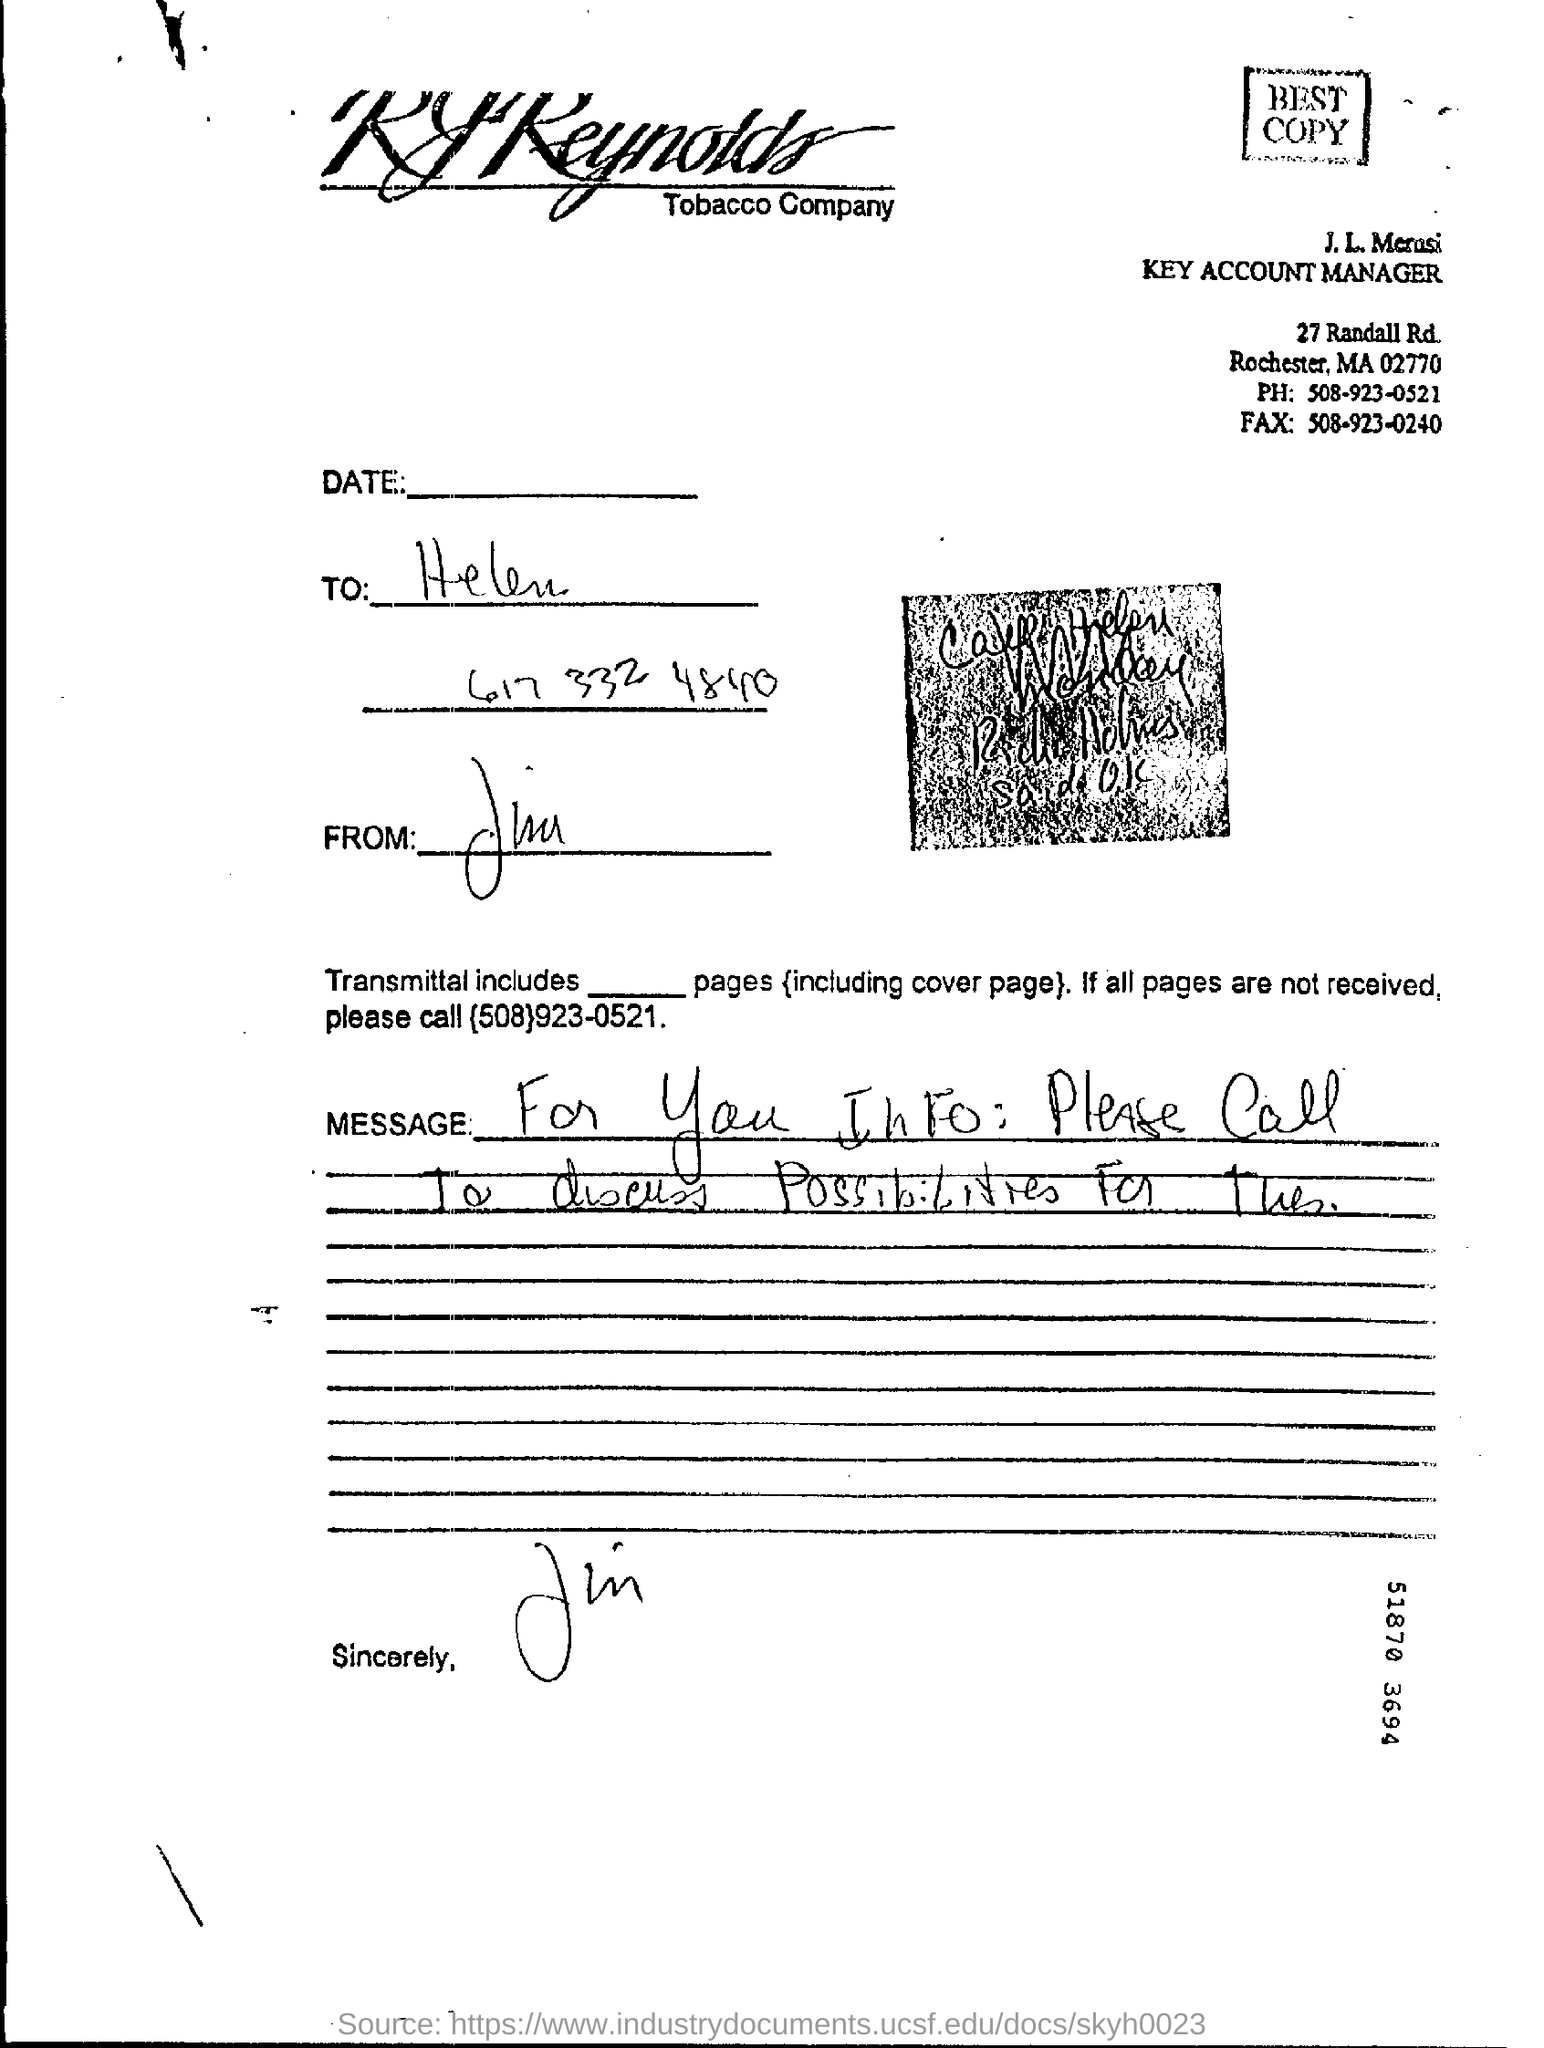what is the phone no mentioned in the letter ? The phone number mentioned in the letter is 508-923-0521. This number appears as part of the contact information provided for addressing further queries or follow-ups related to the contents of the letter. 